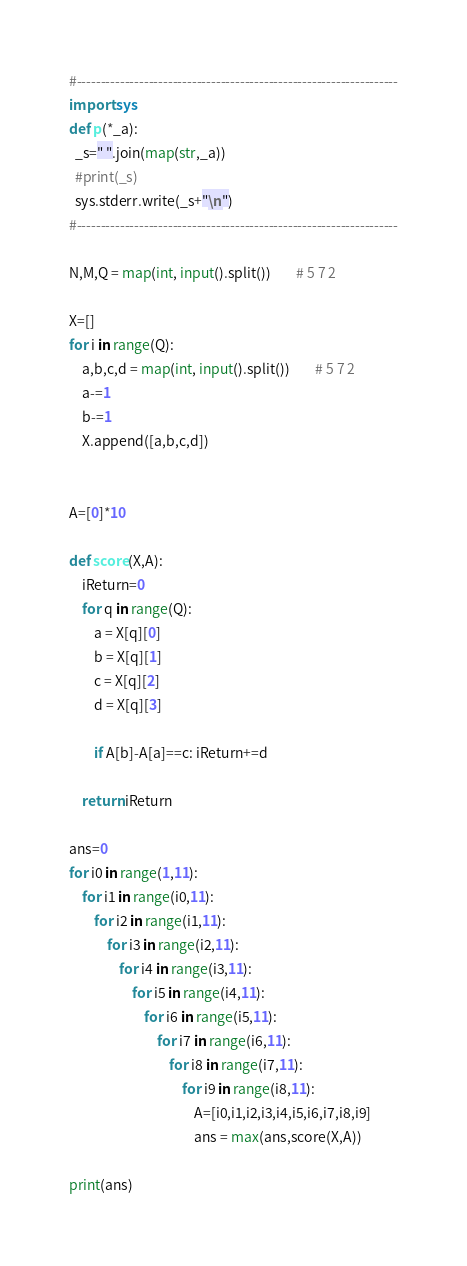Convert code to text. <code><loc_0><loc_0><loc_500><loc_500><_Python_>#-------------------------------------------------------------------
import sys
def p(*_a):
  _s=" ".join(map(str,_a))
  #print(_s)
  sys.stderr.write(_s+"\n")
#-------------------------------------------------------------------

N,M,Q = map(int, input().split())		# 5 7 2

X=[]
for i in range(Q):
	a,b,c,d = map(int, input().split())		# 5 7 2
	a-=1
	b-=1
	X.append([a,b,c,d])


A=[0]*10

def score(X,A):
	iReturn=0
	for q in range(Q):
		a = X[q][0]
		b = X[q][1]
		c = X[q][2]
		d = X[q][3]
		
		if A[b]-A[a]==c: iReturn+=d
	
	return iReturn

ans=0
for i0 in range(1,11):
	for i1 in range(i0,11):
		for i2 in range(i1,11):
			for i3 in range(i2,11):
				for i4 in range(i3,11):
					for i5 in range(i4,11):
						for i6 in range(i5,11):
							for i7 in range(i6,11):
								for i8 in range(i7,11):
									for i9 in range(i8,11):
										A=[i0,i1,i2,i3,i4,i5,i6,i7,i8,i9]
										ans = max(ans,score(X,A))

print(ans)

</code> 